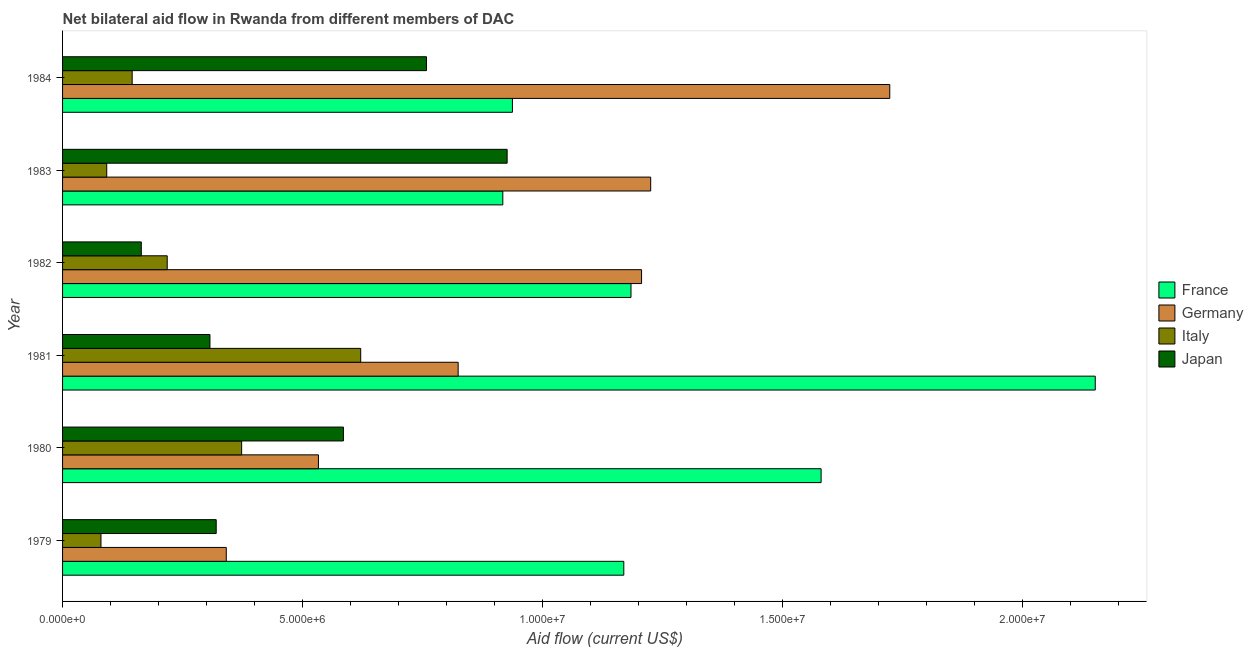How many groups of bars are there?
Offer a terse response. 6. Are the number of bars per tick equal to the number of legend labels?
Your answer should be very brief. Yes. How many bars are there on the 3rd tick from the top?
Ensure brevity in your answer.  4. How many bars are there on the 2nd tick from the bottom?
Offer a very short reply. 4. What is the amount of aid given by germany in 1979?
Offer a terse response. 3.41e+06. Across all years, what is the maximum amount of aid given by germany?
Make the answer very short. 1.72e+07. Across all years, what is the minimum amount of aid given by germany?
Your answer should be very brief. 3.41e+06. What is the total amount of aid given by japan in the graph?
Your answer should be very brief. 3.06e+07. What is the difference between the amount of aid given by italy in 1982 and that in 1983?
Your answer should be very brief. 1.26e+06. What is the difference between the amount of aid given by france in 1980 and the amount of aid given by germany in 1984?
Your answer should be compact. -1.43e+06. What is the average amount of aid given by germany per year?
Keep it short and to the point. 9.75e+06. In the year 1984, what is the difference between the amount of aid given by france and amount of aid given by japan?
Offer a very short reply. 1.79e+06. What is the ratio of the amount of aid given by italy in 1979 to that in 1984?
Keep it short and to the point. 0.55. What is the difference between the highest and the second highest amount of aid given by italy?
Keep it short and to the point. 2.48e+06. What is the difference between the highest and the lowest amount of aid given by italy?
Provide a succinct answer. 5.41e+06. In how many years, is the amount of aid given by japan greater than the average amount of aid given by japan taken over all years?
Provide a short and direct response. 3. Is it the case that in every year, the sum of the amount of aid given by italy and amount of aid given by japan is greater than the sum of amount of aid given by france and amount of aid given by germany?
Your answer should be very brief. No. What does the 1st bar from the top in 1981 represents?
Your response must be concise. Japan. What does the 4th bar from the bottom in 1981 represents?
Provide a short and direct response. Japan. Is it the case that in every year, the sum of the amount of aid given by france and amount of aid given by germany is greater than the amount of aid given by italy?
Your answer should be compact. Yes. How many bars are there?
Make the answer very short. 24. Are all the bars in the graph horizontal?
Give a very brief answer. Yes. How many years are there in the graph?
Make the answer very short. 6. Does the graph contain grids?
Provide a short and direct response. No. Where does the legend appear in the graph?
Keep it short and to the point. Center right. How many legend labels are there?
Your answer should be compact. 4. How are the legend labels stacked?
Provide a succinct answer. Vertical. What is the title of the graph?
Provide a short and direct response. Net bilateral aid flow in Rwanda from different members of DAC. Does "Regional development banks" appear as one of the legend labels in the graph?
Your answer should be compact. No. What is the label or title of the X-axis?
Offer a very short reply. Aid flow (current US$). What is the label or title of the Y-axis?
Provide a short and direct response. Year. What is the Aid flow (current US$) in France in 1979?
Your response must be concise. 1.17e+07. What is the Aid flow (current US$) of Germany in 1979?
Offer a terse response. 3.41e+06. What is the Aid flow (current US$) of Japan in 1979?
Give a very brief answer. 3.20e+06. What is the Aid flow (current US$) in France in 1980?
Provide a short and direct response. 1.58e+07. What is the Aid flow (current US$) of Germany in 1980?
Give a very brief answer. 5.33e+06. What is the Aid flow (current US$) in Italy in 1980?
Provide a succinct answer. 3.73e+06. What is the Aid flow (current US$) of Japan in 1980?
Ensure brevity in your answer.  5.85e+06. What is the Aid flow (current US$) in France in 1981?
Give a very brief answer. 2.15e+07. What is the Aid flow (current US$) in Germany in 1981?
Provide a succinct answer. 8.24e+06. What is the Aid flow (current US$) in Italy in 1981?
Offer a terse response. 6.21e+06. What is the Aid flow (current US$) in Japan in 1981?
Keep it short and to the point. 3.07e+06. What is the Aid flow (current US$) of France in 1982?
Ensure brevity in your answer.  1.18e+07. What is the Aid flow (current US$) in Germany in 1982?
Keep it short and to the point. 1.21e+07. What is the Aid flow (current US$) of Italy in 1982?
Ensure brevity in your answer.  2.18e+06. What is the Aid flow (current US$) in Japan in 1982?
Give a very brief answer. 1.64e+06. What is the Aid flow (current US$) of France in 1983?
Provide a short and direct response. 9.17e+06. What is the Aid flow (current US$) in Germany in 1983?
Provide a short and direct response. 1.22e+07. What is the Aid flow (current US$) of Italy in 1983?
Offer a terse response. 9.20e+05. What is the Aid flow (current US$) of Japan in 1983?
Provide a short and direct response. 9.26e+06. What is the Aid flow (current US$) of France in 1984?
Your answer should be compact. 9.37e+06. What is the Aid flow (current US$) of Germany in 1984?
Offer a very short reply. 1.72e+07. What is the Aid flow (current US$) in Italy in 1984?
Offer a very short reply. 1.45e+06. What is the Aid flow (current US$) in Japan in 1984?
Your answer should be very brief. 7.58e+06. Across all years, what is the maximum Aid flow (current US$) in France?
Your answer should be very brief. 2.15e+07. Across all years, what is the maximum Aid flow (current US$) in Germany?
Offer a very short reply. 1.72e+07. Across all years, what is the maximum Aid flow (current US$) in Italy?
Ensure brevity in your answer.  6.21e+06. Across all years, what is the maximum Aid flow (current US$) of Japan?
Your answer should be compact. 9.26e+06. Across all years, what is the minimum Aid flow (current US$) in France?
Your response must be concise. 9.17e+06. Across all years, what is the minimum Aid flow (current US$) in Germany?
Keep it short and to the point. 3.41e+06. Across all years, what is the minimum Aid flow (current US$) of Italy?
Provide a succinct answer. 8.00e+05. Across all years, what is the minimum Aid flow (current US$) of Japan?
Provide a succinct answer. 1.64e+06. What is the total Aid flow (current US$) of France in the graph?
Your answer should be very brief. 7.94e+07. What is the total Aid flow (current US$) in Germany in the graph?
Offer a very short reply. 5.85e+07. What is the total Aid flow (current US$) in Italy in the graph?
Provide a short and direct response. 1.53e+07. What is the total Aid flow (current US$) of Japan in the graph?
Provide a short and direct response. 3.06e+07. What is the difference between the Aid flow (current US$) of France in 1979 and that in 1980?
Your answer should be compact. -4.11e+06. What is the difference between the Aid flow (current US$) of Germany in 1979 and that in 1980?
Your answer should be compact. -1.92e+06. What is the difference between the Aid flow (current US$) of Italy in 1979 and that in 1980?
Provide a short and direct response. -2.93e+06. What is the difference between the Aid flow (current US$) in Japan in 1979 and that in 1980?
Make the answer very short. -2.65e+06. What is the difference between the Aid flow (current US$) in France in 1979 and that in 1981?
Provide a succinct answer. -9.82e+06. What is the difference between the Aid flow (current US$) of Germany in 1979 and that in 1981?
Offer a very short reply. -4.83e+06. What is the difference between the Aid flow (current US$) of Italy in 1979 and that in 1981?
Make the answer very short. -5.41e+06. What is the difference between the Aid flow (current US$) of Japan in 1979 and that in 1981?
Offer a very short reply. 1.30e+05. What is the difference between the Aid flow (current US$) in Germany in 1979 and that in 1982?
Give a very brief answer. -8.65e+06. What is the difference between the Aid flow (current US$) in Italy in 1979 and that in 1982?
Your answer should be very brief. -1.38e+06. What is the difference between the Aid flow (current US$) of Japan in 1979 and that in 1982?
Your answer should be very brief. 1.56e+06. What is the difference between the Aid flow (current US$) of France in 1979 and that in 1983?
Your answer should be very brief. 2.52e+06. What is the difference between the Aid flow (current US$) in Germany in 1979 and that in 1983?
Provide a succinct answer. -8.84e+06. What is the difference between the Aid flow (current US$) of Italy in 1979 and that in 1983?
Your response must be concise. -1.20e+05. What is the difference between the Aid flow (current US$) of Japan in 1979 and that in 1983?
Provide a short and direct response. -6.06e+06. What is the difference between the Aid flow (current US$) of France in 1979 and that in 1984?
Provide a short and direct response. 2.32e+06. What is the difference between the Aid flow (current US$) of Germany in 1979 and that in 1984?
Give a very brief answer. -1.38e+07. What is the difference between the Aid flow (current US$) in Italy in 1979 and that in 1984?
Make the answer very short. -6.50e+05. What is the difference between the Aid flow (current US$) in Japan in 1979 and that in 1984?
Keep it short and to the point. -4.38e+06. What is the difference between the Aid flow (current US$) of France in 1980 and that in 1981?
Make the answer very short. -5.71e+06. What is the difference between the Aid flow (current US$) of Germany in 1980 and that in 1981?
Your answer should be very brief. -2.91e+06. What is the difference between the Aid flow (current US$) in Italy in 1980 and that in 1981?
Ensure brevity in your answer.  -2.48e+06. What is the difference between the Aid flow (current US$) in Japan in 1980 and that in 1981?
Keep it short and to the point. 2.78e+06. What is the difference between the Aid flow (current US$) of France in 1980 and that in 1982?
Offer a terse response. 3.96e+06. What is the difference between the Aid flow (current US$) of Germany in 1980 and that in 1982?
Offer a very short reply. -6.73e+06. What is the difference between the Aid flow (current US$) in Italy in 1980 and that in 1982?
Offer a very short reply. 1.55e+06. What is the difference between the Aid flow (current US$) of Japan in 1980 and that in 1982?
Give a very brief answer. 4.21e+06. What is the difference between the Aid flow (current US$) of France in 1980 and that in 1983?
Ensure brevity in your answer.  6.63e+06. What is the difference between the Aid flow (current US$) of Germany in 1980 and that in 1983?
Make the answer very short. -6.92e+06. What is the difference between the Aid flow (current US$) in Italy in 1980 and that in 1983?
Ensure brevity in your answer.  2.81e+06. What is the difference between the Aid flow (current US$) of Japan in 1980 and that in 1983?
Keep it short and to the point. -3.41e+06. What is the difference between the Aid flow (current US$) in France in 1980 and that in 1984?
Make the answer very short. 6.43e+06. What is the difference between the Aid flow (current US$) of Germany in 1980 and that in 1984?
Ensure brevity in your answer.  -1.19e+07. What is the difference between the Aid flow (current US$) in Italy in 1980 and that in 1984?
Provide a succinct answer. 2.28e+06. What is the difference between the Aid flow (current US$) in Japan in 1980 and that in 1984?
Make the answer very short. -1.73e+06. What is the difference between the Aid flow (current US$) in France in 1981 and that in 1982?
Your answer should be compact. 9.67e+06. What is the difference between the Aid flow (current US$) in Germany in 1981 and that in 1982?
Keep it short and to the point. -3.82e+06. What is the difference between the Aid flow (current US$) of Italy in 1981 and that in 1982?
Your answer should be compact. 4.03e+06. What is the difference between the Aid flow (current US$) in Japan in 1981 and that in 1982?
Your response must be concise. 1.43e+06. What is the difference between the Aid flow (current US$) in France in 1981 and that in 1983?
Ensure brevity in your answer.  1.23e+07. What is the difference between the Aid flow (current US$) of Germany in 1981 and that in 1983?
Keep it short and to the point. -4.01e+06. What is the difference between the Aid flow (current US$) of Italy in 1981 and that in 1983?
Your answer should be compact. 5.29e+06. What is the difference between the Aid flow (current US$) in Japan in 1981 and that in 1983?
Give a very brief answer. -6.19e+06. What is the difference between the Aid flow (current US$) in France in 1981 and that in 1984?
Your answer should be very brief. 1.21e+07. What is the difference between the Aid flow (current US$) in Germany in 1981 and that in 1984?
Provide a short and direct response. -8.99e+06. What is the difference between the Aid flow (current US$) in Italy in 1981 and that in 1984?
Your answer should be very brief. 4.76e+06. What is the difference between the Aid flow (current US$) of Japan in 1981 and that in 1984?
Offer a very short reply. -4.51e+06. What is the difference between the Aid flow (current US$) of France in 1982 and that in 1983?
Your answer should be very brief. 2.67e+06. What is the difference between the Aid flow (current US$) of Germany in 1982 and that in 1983?
Your answer should be very brief. -1.90e+05. What is the difference between the Aid flow (current US$) in Italy in 1982 and that in 1983?
Provide a succinct answer. 1.26e+06. What is the difference between the Aid flow (current US$) in Japan in 1982 and that in 1983?
Make the answer very short. -7.62e+06. What is the difference between the Aid flow (current US$) of France in 1982 and that in 1984?
Your answer should be compact. 2.47e+06. What is the difference between the Aid flow (current US$) of Germany in 1982 and that in 1984?
Give a very brief answer. -5.17e+06. What is the difference between the Aid flow (current US$) of Italy in 1982 and that in 1984?
Ensure brevity in your answer.  7.30e+05. What is the difference between the Aid flow (current US$) in Japan in 1982 and that in 1984?
Offer a very short reply. -5.94e+06. What is the difference between the Aid flow (current US$) of France in 1983 and that in 1984?
Provide a succinct answer. -2.00e+05. What is the difference between the Aid flow (current US$) of Germany in 1983 and that in 1984?
Ensure brevity in your answer.  -4.98e+06. What is the difference between the Aid flow (current US$) in Italy in 1983 and that in 1984?
Your answer should be very brief. -5.30e+05. What is the difference between the Aid flow (current US$) in Japan in 1983 and that in 1984?
Provide a short and direct response. 1.68e+06. What is the difference between the Aid flow (current US$) of France in 1979 and the Aid flow (current US$) of Germany in 1980?
Your answer should be compact. 6.36e+06. What is the difference between the Aid flow (current US$) in France in 1979 and the Aid flow (current US$) in Italy in 1980?
Offer a terse response. 7.96e+06. What is the difference between the Aid flow (current US$) in France in 1979 and the Aid flow (current US$) in Japan in 1980?
Offer a terse response. 5.84e+06. What is the difference between the Aid flow (current US$) of Germany in 1979 and the Aid flow (current US$) of Italy in 1980?
Make the answer very short. -3.20e+05. What is the difference between the Aid flow (current US$) of Germany in 1979 and the Aid flow (current US$) of Japan in 1980?
Keep it short and to the point. -2.44e+06. What is the difference between the Aid flow (current US$) in Italy in 1979 and the Aid flow (current US$) in Japan in 1980?
Provide a succinct answer. -5.05e+06. What is the difference between the Aid flow (current US$) in France in 1979 and the Aid flow (current US$) in Germany in 1981?
Your response must be concise. 3.45e+06. What is the difference between the Aid flow (current US$) in France in 1979 and the Aid flow (current US$) in Italy in 1981?
Offer a very short reply. 5.48e+06. What is the difference between the Aid flow (current US$) in France in 1979 and the Aid flow (current US$) in Japan in 1981?
Your response must be concise. 8.62e+06. What is the difference between the Aid flow (current US$) in Germany in 1979 and the Aid flow (current US$) in Italy in 1981?
Your response must be concise. -2.80e+06. What is the difference between the Aid flow (current US$) in Italy in 1979 and the Aid flow (current US$) in Japan in 1981?
Ensure brevity in your answer.  -2.27e+06. What is the difference between the Aid flow (current US$) in France in 1979 and the Aid flow (current US$) in Germany in 1982?
Offer a very short reply. -3.70e+05. What is the difference between the Aid flow (current US$) in France in 1979 and the Aid flow (current US$) in Italy in 1982?
Offer a very short reply. 9.51e+06. What is the difference between the Aid flow (current US$) of France in 1979 and the Aid flow (current US$) of Japan in 1982?
Give a very brief answer. 1.00e+07. What is the difference between the Aid flow (current US$) in Germany in 1979 and the Aid flow (current US$) in Italy in 1982?
Offer a terse response. 1.23e+06. What is the difference between the Aid flow (current US$) in Germany in 1979 and the Aid flow (current US$) in Japan in 1982?
Offer a terse response. 1.77e+06. What is the difference between the Aid flow (current US$) in Italy in 1979 and the Aid flow (current US$) in Japan in 1982?
Make the answer very short. -8.40e+05. What is the difference between the Aid flow (current US$) of France in 1979 and the Aid flow (current US$) of Germany in 1983?
Give a very brief answer. -5.60e+05. What is the difference between the Aid flow (current US$) of France in 1979 and the Aid flow (current US$) of Italy in 1983?
Make the answer very short. 1.08e+07. What is the difference between the Aid flow (current US$) in France in 1979 and the Aid flow (current US$) in Japan in 1983?
Give a very brief answer. 2.43e+06. What is the difference between the Aid flow (current US$) of Germany in 1979 and the Aid flow (current US$) of Italy in 1983?
Ensure brevity in your answer.  2.49e+06. What is the difference between the Aid flow (current US$) in Germany in 1979 and the Aid flow (current US$) in Japan in 1983?
Offer a very short reply. -5.85e+06. What is the difference between the Aid flow (current US$) in Italy in 1979 and the Aid flow (current US$) in Japan in 1983?
Provide a short and direct response. -8.46e+06. What is the difference between the Aid flow (current US$) of France in 1979 and the Aid flow (current US$) of Germany in 1984?
Offer a terse response. -5.54e+06. What is the difference between the Aid flow (current US$) in France in 1979 and the Aid flow (current US$) in Italy in 1984?
Provide a succinct answer. 1.02e+07. What is the difference between the Aid flow (current US$) of France in 1979 and the Aid flow (current US$) of Japan in 1984?
Provide a succinct answer. 4.11e+06. What is the difference between the Aid flow (current US$) of Germany in 1979 and the Aid flow (current US$) of Italy in 1984?
Offer a very short reply. 1.96e+06. What is the difference between the Aid flow (current US$) of Germany in 1979 and the Aid flow (current US$) of Japan in 1984?
Keep it short and to the point. -4.17e+06. What is the difference between the Aid flow (current US$) in Italy in 1979 and the Aid flow (current US$) in Japan in 1984?
Provide a short and direct response. -6.78e+06. What is the difference between the Aid flow (current US$) in France in 1980 and the Aid flow (current US$) in Germany in 1981?
Give a very brief answer. 7.56e+06. What is the difference between the Aid flow (current US$) in France in 1980 and the Aid flow (current US$) in Italy in 1981?
Your answer should be very brief. 9.59e+06. What is the difference between the Aid flow (current US$) of France in 1980 and the Aid flow (current US$) of Japan in 1981?
Your answer should be very brief. 1.27e+07. What is the difference between the Aid flow (current US$) of Germany in 1980 and the Aid flow (current US$) of Italy in 1981?
Make the answer very short. -8.80e+05. What is the difference between the Aid flow (current US$) in Germany in 1980 and the Aid flow (current US$) in Japan in 1981?
Provide a succinct answer. 2.26e+06. What is the difference between the Aid flow (current US$) in Italy in 1980 and the Aid flow (current US$) in Japan in 1981?
Provide a succinct answer. 6.60e+05. What is the difference between the Aid flow (current US$) of France in 1980 and the Aid flow (current US$) of Germany in 1982?
Make the answer very short. 3.74e+06. What is the difference between the Aid flow (current US$) of France in 1980 and the Aid flow (current US$) of Italy in 1982?
Your response must be concise. 1.36e+07. What is the difference between the Aid flow (current US$) in France in 1980 and the Aid flow (current US$) in Japan in 1982?
Provide a succinct answer. 1.42e+07. What is the difference between the Aid flow (current US$) of Germany in 1980 and the Aid flow (current US$) of Italy in 1982?
Provide a short and direct response. 3.15e+06. What is the difference between the Aid flow (current US$) in Germany in 1980 and the Aid flow (current US$) in Japan in 1982?
Your answer should be compact. 3.69e+06. What is the difference between the Aid flow (current US$) in Italy in 1980 and the Aid flow (current US$) in Japan in 1982?
Your answer should be very brief. 2.09e+06. What is the difference between the Aid flow (current US$) of France in 1980 and the Aid flow (current US$) of Germany in 1983?
Offer a terse response. 3.55e+06. What is the difference between the Aid flow (current US$) of France in 1980 and the Aid flow (current US$) of Italy in 1983?
Offer a terse response. 1.49e+07. What is the difference between the Aid flow (current US$) in France in 1980 and the Aid flow (current US$) in Japan in 1983?
Give a very brief answer. 6.54e+06. What is the difference between the Aid flow (current US$) of Germany in 1980 and the Aid flow (current US$) of Italy in 1983?
Your response must be concise. 4.41e+06. What is the difference between the Aid flow (current US$) in Germany in 1980 and the Aid flow (current US$) in Japan in 1983?
Your response must be concise. -3.93e+06. What is the difference between the Aid flow (current US$) in Italy in 1980 and the Aid flow (current US$) in Japan in 1983?
Offer a very short reply. -5.53e+06. What is the difference between the Aid flow (current US$) of France in 1980 and the Aid flow (current US$) of Germany in 1984?
Your answer should be very brief. -1.43e+06. What is the difference between the Aid flow (current US$) in France in 1980 and the Aid flow (current US$) in Italy in 1984?
Your answer should be compact. 1.44e+07. What is the difference between the Aid flow (current US$) of France in 1980 and the Aid flow (current US$) of Japan in 1984?
Offer a very short reply. 8.22e+06. What is the difference between the Aid flow (current US$) of Germany in 1980 and the Aid flow (current US$) of Italy in 1984?
Provide a succinct answer. 3.88e+06. What is the difference between the Aid flow (current US$) in Germany in 1980 and the Aid flow (current US$) in Japan in 1984?
Your answer should be very brief. -2.25e+06. What is the difference between the Aid flow (current US$) in Italy in 1980 and the Aid flow (current US$) in Japan in 1984?
Your answer should be compact. -3.85e+06. What is the difference between the Aid flow (current US$) of France in 1981 and the Aid flow (current US$) of Germany in 1982?
Ensure brevity in your answer.  9.45e+06. What is the difference between the Aid flow (current US$) of France in 1981 and the Aid flow (current US$) of Italy in 1982?
Your answer should be compact. 1.93e+07. What is the difference between the Aid flow (current US$) of France in 1981 and the Aid flow (current US$) of Japan in 1982?
Your answer should be compact. 1.99e+07. What is the difference between the Aid flow (current US$) in Germany in 1981 and the Aid flow (current US$) in Italy in 1982?
Give a very brief answer. 6.06e+06. What is the difference between the Aid flow (current US$) in Germany in 1981 and the Aid flow (current US$) in Japan in 1982?
Your answer should be compact. 6.60e+06. What is the difference between the Aid flow (current US$) in Italy in 1981 and the Aid flow (current US$) in Japan in 1982?
Provide a short and direct response. 4.57e+06. What is the difference between the Aid flow (current US$) in France in 1981 and the Aid flow (current US$) in Germany in 1983?
Your answer should be compact. 9.26e+06. What is the difference between the Aid flow (current US$) in France in 1981 and the Aid flow (current US$) in Italy in 1983?
Ensure brevity in your answer.  2.06e+07. What is the difference between the Aid flow (current US$) of France in 1981 and the Aid flow (current US$) of Japan in 1983?
Make the answer very short. 1.22e+07. What is the difference between the Aid flow (current US$) in Germany in 1981 and the Aid flow (current US$) in Italy in 1983?
Your response must be concise. 7.32e+06. What is the difference between the Aid flow (current US$) of Germany in 1981 and the Aid flow (current US$) of Japan in 1983?
Give a very brief answer. -1.02e+06. What is the difference between the Aid flow (current US$) in Italy in 1981 and the Aid flow (current US$) in Japan in 1983?
Your answer should be compact. -3.05e+06. What is the difference between the Aid flow (current US$) of France in 1981 and the Aid flow (current US$) of Germany in 1984?
Keep it short and to the point. 4.28e+06. What is the difference between the Aid flow (current US$) in France in 1981 and the Aid flow (current US$) in Italy in 1984?
Your answer should be compact. 2.01e+07. What is the difference between the Aid flow (current US$) of France in 1981 and the Aid flow (current US$) of Japan in 1984?
Offer a very short reply. 1.39e+07. What is the difference between the Aid flow (current US$) in Germany in 1981 and the Aid flow (current US$) in Italy in 1984?
Offer a very short reply. 6.79e+06. What is the difference between the Aid flow (current US$) of Italy in 1981 and the Aid flow (current US$) of Japan in 1984?
Your answer should be very brief. -1.37e+06. What is the difference between the Aid flow (current US$) of France in 1982 and the Aid flow (current US$) of Germany in 1983?
Keep it short and to the point. -4.10e+05. What is the difference between the Aid flow (current US$) of France in 1982 and the Aid flow (current US$) of Italy in 1983?
Give a very brief answer. 1.09e+07. What is the difference between the Aid flow (current US$) of France in 1982 and the Aid flow (current US$) of Japan in 1983?
Offer a very short reply. 2.58e+06. What is the difference between the Aid flow (current US$) of Germany in 1982 and the Aid flow (current US$) of Italy in 1983?
Make the answer very short. 1.11e+07. What is the difference between the Aid flow (current US$) of Germany in 1982 and the Aid flow (current US$) of Japan in 1983?
Your answer should be compact. 2.80e+06. What is the difference between the Aid flow (current US$) of Italy in 1982 and the Aid flow (current US$) of Japan in 1983?
Ensure brevity in your answer.  -7.08e+06. What is the difference between the Aid flow (current US$) in France in 1982 and the Aid flow (current US$) in Germany in 1984?
Your answer should be compact. -5.39e+06. What is the difference between the Aid flow (current US$) of France in 1982 and the Aid flow (current US$) of Italy in 1984?
Your answer should be very brief. 1.04e+07. What is the difference between the Aid flow (current US$) of France in 1982 and the Aid flow (current US$) of Japan in 1984?
Give a very brief answer. 4.26e+06. What is the difference between the Aid flow (current US$) of Germany in 1982 and the Aid flow (current US$) of Italy in 1984?
Your answer should be very brief. 1.06e+07. What is the difference between the Aid flow (current US$) in Germany in 1982 and the Aid flow (current US$) in Japan in 1984?
Make the answer very short. 4.48e+06. What is the difference between the Aid flow (current US$) in Italy in 1982 and the Aid flow (current US$) in Japan in 1984?
Keep it short and to the point. -5.40e+06. What is the difference between the Aid flow (current US$) in France in 1983 and the Aid flow (current US$) in Germany in 1984?
Offer a terse response. -8.06e+06. What is the difference between the Aid flow (current US$) in France in 1983 and the Aid flow (current US$) in Italy in 1984?
Your answer should be compact. 7.72e+06. What is the difference between the Aid flow (current US$) in France in 1983 and the Aid flow (current US$) in Japan in 1984?
Keep it short and to the point. 1.59e+06. What is the difference between the Aid flow (current US$) in Germany in 1983 and the Aid flow (current US$) in Italy in 1984?
Offer a terse response. 1.08e+07. What is the difference between the Aid flow (current US$) in Germany in 1983 and the Aid flow (current US$) in Japan in 1984?
Give a very brief answer. 4.67e+06. What is the difference between the Aid flow (current US$) of Italy in 1983 and the Aid flow (current US$) of Japan in 1984?
Your response must be concise. -6.66e+06. What is the average Aid flow (current US$) of France per year?
Make the answer very short. 1.32e+07. What is the average Aid flow (current US$) in Germany per year?
Your answer should be very brief. 9.75e+06. What is the average Aid flow (current US$) in Italy per year?
Provide a short and direct response. 2.55e+06. What is the average Aid flow (current US$) in Japan per year?
Provide a succinct answer. 5.10e+06. In the year 1979, what is the difference between the Aid flow (current US$) in France and Aid flow (current US$) in Germany?
Make the answer very short. 8.28e+06. In the year 1979, what is the difference between the Aid flow (current US$) of France and Aid flow (current US$) of Italy?
Give a very brief answer. 1.09e+07. In the year 1979, what is the difference between the Aid flow (current US$) in France and Aid flow (current US$) in Japan?
Ensure brevity in your answer.  8.49e+06. In the year 1979, what is the difference between the Aid flow (current US$) in Germany and Aid flow (current US$) in Italy?
Keep it short and to the point. 2.61e+06. In the year 1979, what is the difference between the Aid flow (current US$) of Italy and Aid flow (current US$) of Japan?
Make the answer very short. -2.40e+06. In the year 1980, what is the difference between the Aid flow (current US$) of France and Aid flow (current US$) of Germany?
Give a very brief answer. 1.05e+07. In the year 1980, what is the difference between the Aid flow (current US$) of France and Aid flow (current US$) of Italy?
Provide a succinct answer. 1.21e+07. In the year 1980, what is the difference between the Aid flow (current US$) of France and Aid flow (current US$) of Japan?
Your answer should be very brief. 9.95e+06. In the year 1980, what is the difference between the Aid flow (current US$) in Germany and Aid flow (current US$) in Italy?
Offer a terse response. 1.60e+06. In the year 1980, what is the difference between the Aid flow (current US$) of Germany and Aid flow (current US$) of Japan?
Offer a terse response. -5.20e+05. In the year 1980, what is the difference between the Aid flow (current US$) of Italy and Aid flow (current US$) of Japan?
Provide a short and direct response. -2.12e+06. In the year 1981, what is the difference between the Aid flow (current US$) of France and Aid flow (current US$) of Germany?
Offer a terse response. 1.33e+07. In the year 1981, what is the difference between the Aid flow (current US$) of France and Aid flow (current US$) of Italy?
Ensure brevity in your answer.  1.53e+07. In the year 1981, what is the difference between the Aid flow (current US$) in France and Aid flow (current US$) in Japan?
Provide a succinct answer. 1.84e+07. In the year 1981, what is the difference between the Aid flow (current US$) of Germany and Aid flow (current US$) of Italy?
Offer a terse response. 2.03e+06. In the year 1981, what is the difference between the Aid flow (current US$) of Germany and Aid flow (current US$) of Japan?
Give a very brief answer. 5.17e+06. In the year 1981, what is the difference between the Aid flow (current US$) of Italy and Aid flow (current US$) of Japan?
Keep it short and to the point. 3.14e+06. In the year 1982, what is the difference between the Aid flow (current US$) of France and Aid flow (current US$) of Italy?
Your response must be concise. 9.66e+06. In the year 1982, what is the difference between the Aid flow (current US$) of France and Aid flow (current US$) of Japan?
Your answer should be very brief. 1.02e+07. In the year 1982, what is the difference between the Aid flow (current US$) of Germany and Aid flow (current US$) of Italy?
Provide a short and direct response. 9.88e+06. In the year 1982, what is the difference between the Aid flow (current US$) in Germany and Aid flow (current US$) in Japan?
Offer a terse response. 1.04e+07. In the year 1982, what is the difference between the Aid flow (current US$) of Italy and Aid flow (current US$) of Japan?
Your answer should be very brief. 5.40e+05. In the year 1983, what is the difference between the Aid flow (current US$) of France and Aid flow (current US$) of Germany?
Your answer should be compact. -3.08e+06. In the year 1983, what is the difference between the Aid flow (current US$) of France and Aid flow (current US$) of Italy?
Your answer should be compact. 8.25e+06. In the year 1983, what is the difference between the Aid flow (current US$) in France and Aid flow (current US$) in Japan?
Make the answer very short. -9.00e+04. In the year 1983, what is the difference between the Aid flow (current US$) of Germany and Aid flow (current US$) of Italy?
Your answer should be compact. 1.13e+07. In the year 1983, what is the difference between the Aid flow (current US$) of Germany and Aid flow (current US$) of Japan?
Ensure brevity in your answer.  2.99e+06. In the year 1983, what is the difference between the Aid flow (current US$) of Italy and Aid flow (current US$) of Japan?
Make the answer very short. -8.34e+06. In the year 1984, what is the difference between the Aid flow (current US$) in France and Aid flow (current US$) in Germany?
Your response must be concise. -7.86e+06. In the year 1984, what is the difference between the Aid flow (current US$) of France and Aid flow (current US$) of Italy?
Keep it short and to the point. 7.92e+06. In the year 1984, what is the difference between the Aid flow (current US$) of France and Aid flow (current US$) of Japan?
Your response must be concise. 1.79e+06. In the year 1984, what is the difference between the Aid flow (current US$) in Germany and Aid flow (current US$) in Italy?
Make the answer very short. 1.58e+07. In the year 1984, what is the difference between the Aid flow (current US$) in Germany and Aid flow (current US$) in Japan?
Offer a very short reply. 9.65e+06. In the year 1984, what is the difference between the Aid flow (current US$) of Italy and Aid flow (current US$) of Japan?
Offer a terse response. -6.13e+06. What is the ratio of the Aid flow (current US$) in France in 1979 to that in 1980?
Offer a very short reply. 0.74. What is the ratio of the Aid flow (current US$) in Germany in 1979 to that in 1980?
Provide a short and direct response. 0.64. What is the ratio of the Aid flow (current US$) of Italy in 1979 to that in 1980?
Offer a terse response. 0.21. What is the ratio of the Aid flow (current US$) in Japan in 1979 to that in 1980?
Offer a terse response. 0.55. What is the ratio of the Aid flow (current US$) in France in 1979 to that in 1981?
Offer a very short reply. 0.54. What is the ratio of the Aid flow (current US$) of Germany in 1979 to that in 1981?
Give a very brief answer. 0.41. What is the ratio of the Aid flow (current US$) of Italy in 1979 to that in 1981?
Provide a short and direct response. 0.13. What is the ratio of the Aid flow (current US$) in Japan in 1979 to that in 1981?
Offer a terse response. 1.04. What is the ratio of the Aid flow (current US$) of France in 1979 to that in 1982?
Ensure brevity in your answer.  0.99. What is the ratio of the Aid flow (current US$) in Germany in 1979 to that in 1982?
Your answer should be very brief. 0.28. What is the ratio of the Aid flow (current US$) in Italy in 1979 to that in 1982?
Your response must be concise. 0.37. What is the ratio of the Aid flow (current US$) of Japan in 1979 to that in 1982?
Offer a very short reply. 1.95. What is the ratio of the Aid flow (current US$) of France in 1979 to that in 1983?
Make the answer very short. 1.27. What is the ratio of the Aid flow (current US$) of Germany in 1979 to that in 1983?
Your answer should be compact. 0.28. What is the ratio of the Aid flow (current US$) of Italy in 1979 to that in 1983?
Provide a succinct answer. 0.87. What is the ratio of the Aid flow (current US$) in Japan in 1979 to that in 1983?
Ensure brevity in your answer.  0.35. What is the ratio of the Aid flow (current US$) in France in 1979 to that in 1984?
Give a very brief answer. 1.25. What is the ratio of the Aid flow (current US$) in Germany in 1979 to that in 1984?
Provide a short and direct response. 0.2. What is the ratio of the Aid flow (current US$) of Italy in 1979 to that in 1984?
Ensure brevity in your answer.  0.55. What is the ratio of the Aid flow (current US$) of Japan in 1979 to that in 1984?
Your answer should be very brief. 0.42. What is the ratio of the Aid flow (current US$) of France in 1980 to that in 1981?
Your answer should be very brief. 0.73. What is the ratio of the Aid flow (current US$) of Germany in 1980 to that in 1981?
Offer a very short reply. 0.65. What is the ratio of the Aid flow (current US$) in Italy in 1980 to that in 1981?
Your answer should be compact. 0.6. What is the ratio of the Aid flow (current US$) in Japan in 1980 to that in 1981?
Ensure brevity in your answer.  1.91. What is the ratio of the Aid flow (current US$) in France in 1980 to that in 1982?
Give a very brief answer. 1.33. What is the ratio of the Aid flow (current US$) of Germany in 1980 to that in 1982?
Keep it short and to the point. 0.44. What is the ratio of the Aid flow (current US$) in Italy in 1980 to that in 1982?
Offer a terse response. 1.71. What is the ratio of the Aid flow (current US$) in Japan in 1980 to that in 1982?
Your answer should be very brief. 3.57. What is the ratio of the Aid flow (current US$) in France in 1980 to that in 1983?
Give a very brief answer. 1.72. What is the ratio of the Aid flow (current US$) of Germany in 1980 to that in 1983?
Make the answer very short. 0.44. What is the ratio of the Aid flow (current US$) of Italy in 1980 to that in 1983?
Keep it short and to the point. 4.05. What is the ratio of the Aid flow (current US$) in Japan in 1980 to that in 1983?
Your answer should be very brief. 0.63. What is the ratio of the Aid flow (current US$) of France in 1980 to that in 1984?
Ensure brevity in your answer.  1.69. What is the ratio of the Aid flow (current US$) in Germany in 1980 to that in 1984?
Offer a very short reply. 0.31. What is the ratio of the Aid flow (current US$) in Italy in 1980 to that in 1984?
Your answer should be compact. 2.57. What is the ratio of the Aid flow (current US$) in Japan in 1980 to that in 1984?
Ensure brevity in your answer.  0.77. What is the ratio of the Aid flow (current US$) in France in 1981 to that in 1982?
Ensure brevity in your answer.  1.82. What is the ratio of the Aid flow (current US$) in Germany in 1981 to that in 1982?
Offer a very short reply. 0.68. What is the ratio of the Aid flow (current US$) in Italy in 1981 to that in 1982?
Your answer should be very brief. 2.85. What is the ratio of the Aid flow (current US$) in Japan in 1981 to that in 1982?
Offer a very short reply. 1.87. What is the ratio of the Aid flow (current US$) of France in 1981 to that in 1983?
Ensure brevity in your answer.  2.35. What is the ratio of the Aid flow (current US$) of Germany in 1981 to that in 1983?
Your answer should be compact. 0.67. What is the ratio of the Aid flow (current US$) of Italy in 1981 to that in 1983?
Offer a very short reply. 6.75. What is the ratio of the Aid flow (current US$) in Japan in 1981 to that in 1983?
Give a very brief answer. 0.33. What is the ratio of the Aid flow (current US$) in France in 1981 to that in 1984?
Offer a very short reply. 2.3. What is the ratio of the Aid flow (current US$) in Germany in 1981 to that in 1984?
Keep it short and to the point. 0.48. What is the ratio of the Aid flow (current US$) of Italy in 1981 to that in 1984?
Keep it short and to the point. 4.28. What is the ratio of the Aid flow (current US$) in Japan in 1981 to that in 1984?
Offer a terse response. 0.41. What is the ratio of the Aid flow (current US$) of France in 1982 to that in 1983?
Give a very brief answer. 1.29. What is the ratio of the Aid flow (current US$) of Germany in 1982 to that in 1983?
Your answer should be very brief. 0.98. What is the ratio of the Aid flow (current US$) of Italy in 1982 to that in 1983?
Give a very brief answer. 2.37. What is the ratio of the Aid flow (current US$) of Japan in 1982 to that in 1983?
Provide a succinct answer. 0.18. What is the ratio of the Aid flow (current US$) in France in 1982 to that in 1984?
Provide a succinct answer. 1.26. What is the ratio of the Aid flow (current US$) in Germany in 1982 to that in 1984?
Ensure brevity in your answer.  0.7. What is the ratio of the Aid flow (current US$) in Italy in 1982 to that in 1984?
Your answer should be very brief. 1.5. What is the ratio of the Aid flow (current US$) of Japan in 1982 to that in 1984?
Provide a short and direct response. 0.22. What is the ratio of the Aid flow (current US$) of France in 1983 to that in 1984?
Offer a very short reply. 0.98. What is the ratio of the Aid flow (current US$) of Germany in 1983 to that in 1984?
Give a very brief answer. 0.71. What is the ratio of the Aid flow (current US$) in Italy in 1983 to that in 1984?
Offer a very short reply. 0.63. What is the ratio of the Aid flow (current US$) in Japan in 1983 to that in 1984?
Ensure brevity in your answer.  1.22. What is the difference between the highest and the second highest Aid flow (current US$) in France?
Your response must be concise. 5.71e+06. What is the difference between the highest and the second highest Aid flow (current US$) of Germany?
Your answer should be very brief. 4.98e+06. What is the difference between the highest and the second highest Aid flow (current US$) of Italy?
Your response must be concise. 2.48e+06. What is the difference between the highest and the second highest Aid flow (current US$) in Japan?
Your response must be concise. 1.68e+06. What is the difference between the highest and the lowest Aid flow (current US$) in France?
Provide a short and direct response. 1.23e+07. What is the difference between the highest and the lowest Aid flow (current US$) in Germany?
Your response must be concise. 1.38e+07. What is the difference between the highest and the lowest Aid flow (current US$) in Italy?
Provide a short and direct response. 5.41e+06. What is the difference between the highest and the lowest Aid flow (current US$) of Japan?
Provide a succinct answer. 7.62e+06. 